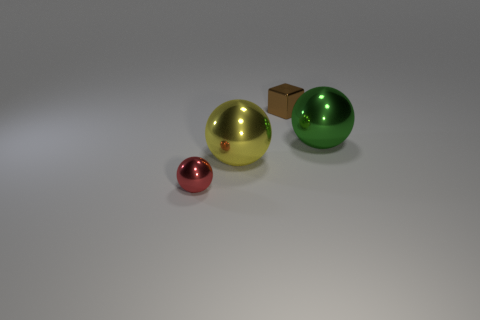Add 4 big gray rubber objects. How many objects exist? 8 Subtract all cubes. How many objects are left? 3 Subtract all brown metal cubes. Subtract all tiny gray metallic things. How many objects are left? 3 Add 2 green metal balls. How many green metal balls are left? 3 Add 4 red shiny objects. How many red shiny objects exist? 5 Subtract 0 blue blocks. How many objects are left? 4 